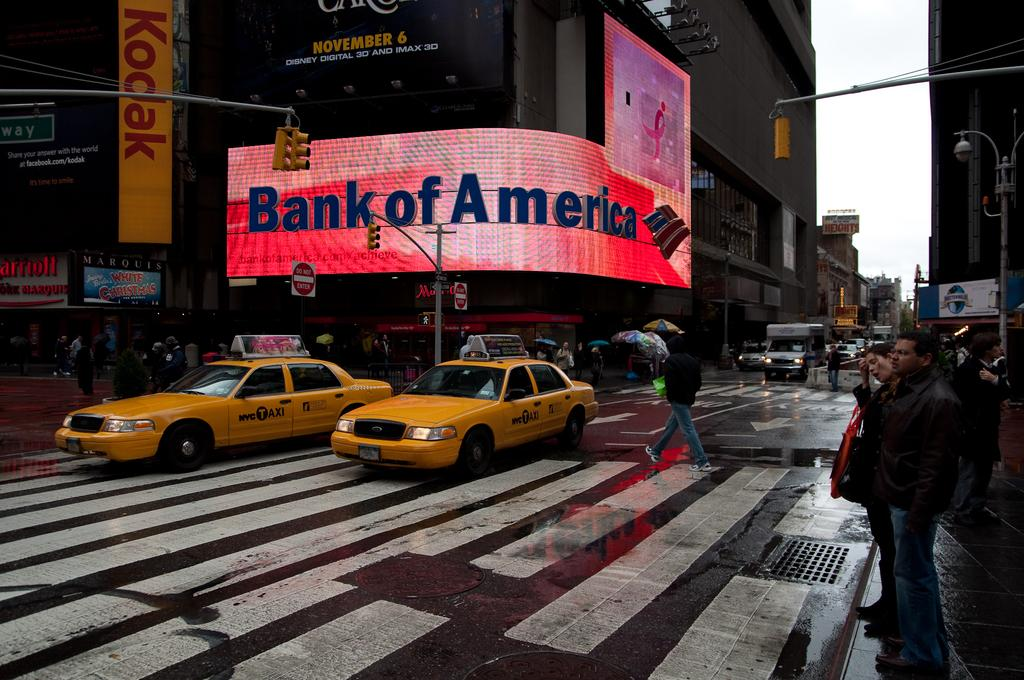What is happening on the road in the image? There are vehicles on the road in the image. Are there any people visible in the image? Yes, there are persons visible in the image. What type of structures can be seen in the image? There are buildings present in the image. What might help regulate the flow of traffic in the image? Traffic signals are observable in the image. What type of rail can be seen in the image? There is no rail present in the image. What season is depicted in the image? The provided facts do not mention any specific season, so it cannot be determined from the image. 